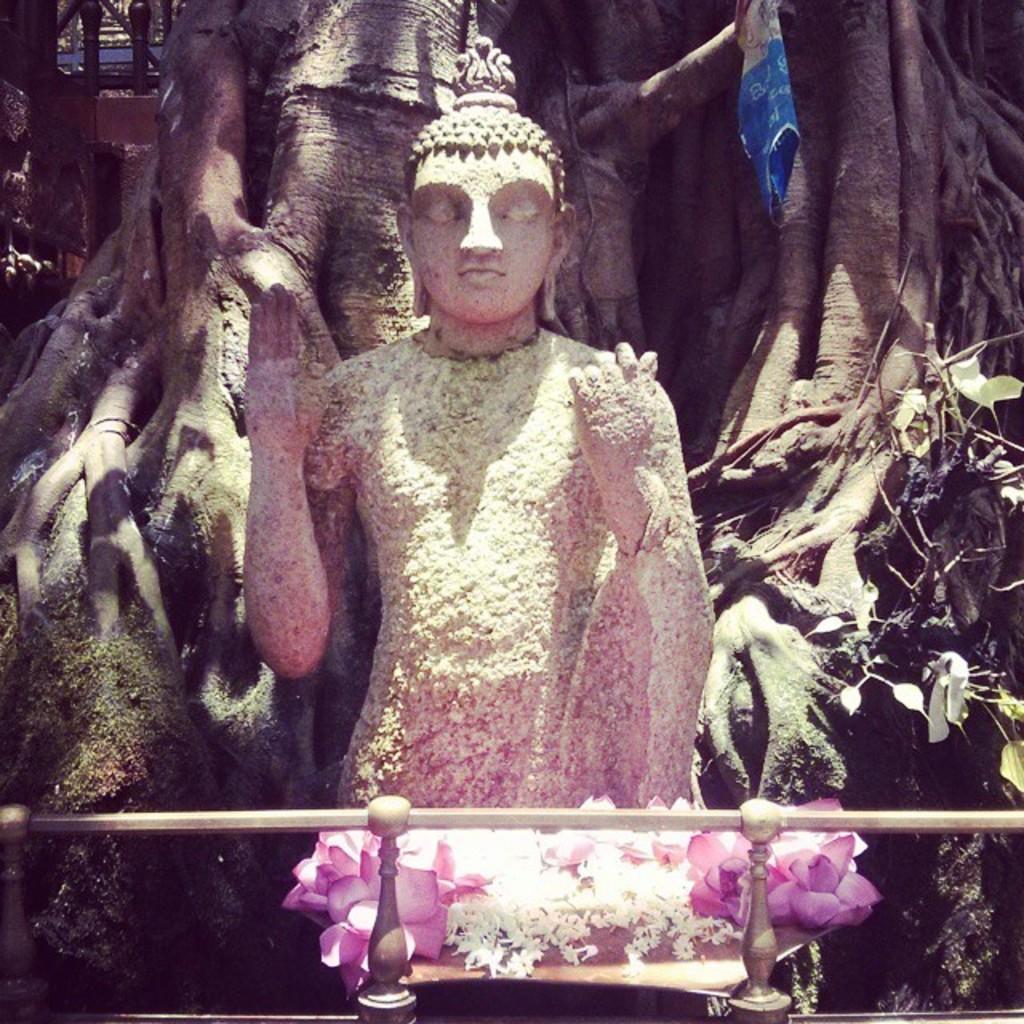Describe this image in one or two sentences. In the picture we can see a Buddha statue near it, we can see some flowers which are pink and white and in the background we can see a tree with roots. 